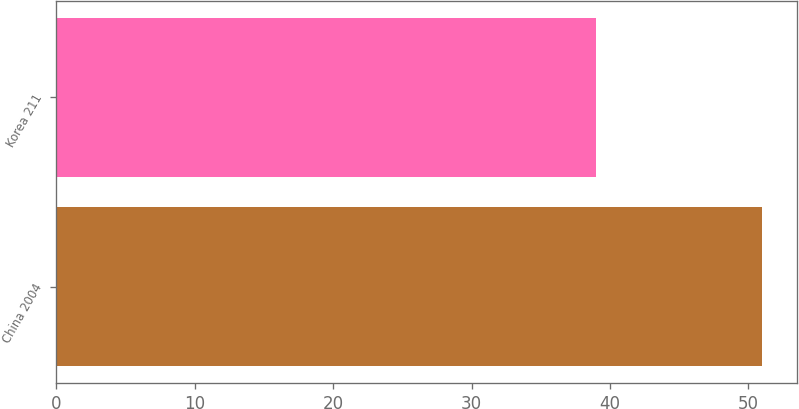<chart> <loc_0><loc_0><loc_500><loc_500><bar_chart><fcel>China 2004<fcel>Korea 211<nl><fcel>51<fcel>39<nl></chart> 